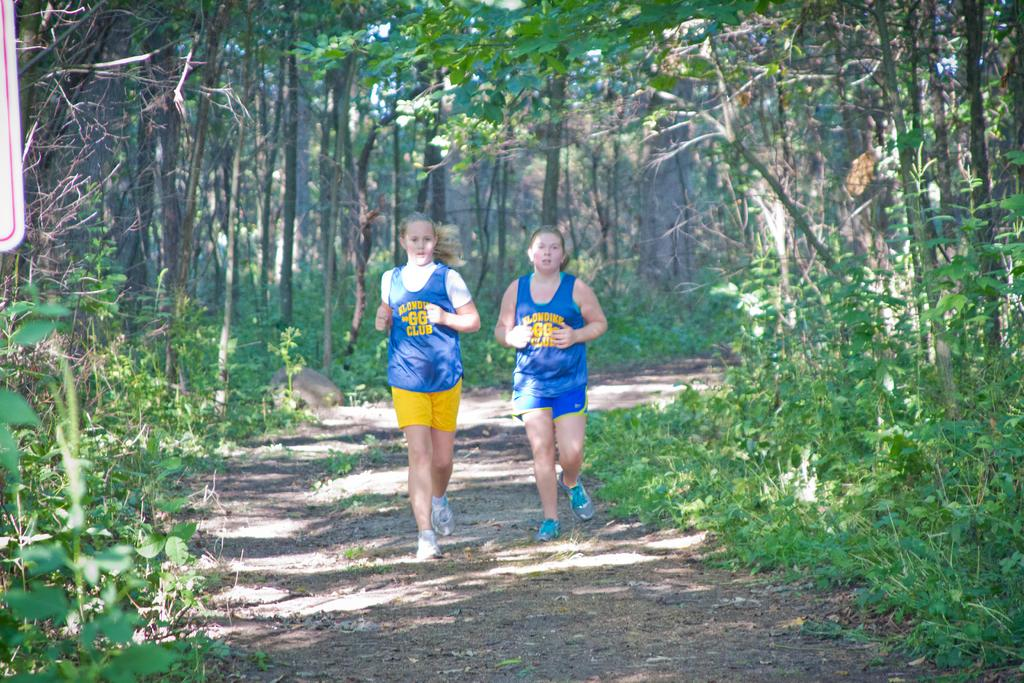How many women are present in the image? There are two women in the image. What are the women doing in the image? The women are running on the ground. What type of natural elements can be seen in the image? There are plants and trees in the image. What type of cord is being used by the women to run in the image? There is no cord visible in the image; the women are running on the ground without any visible cords. What type of fork can be seen in the image? There is no fork present in the image. 